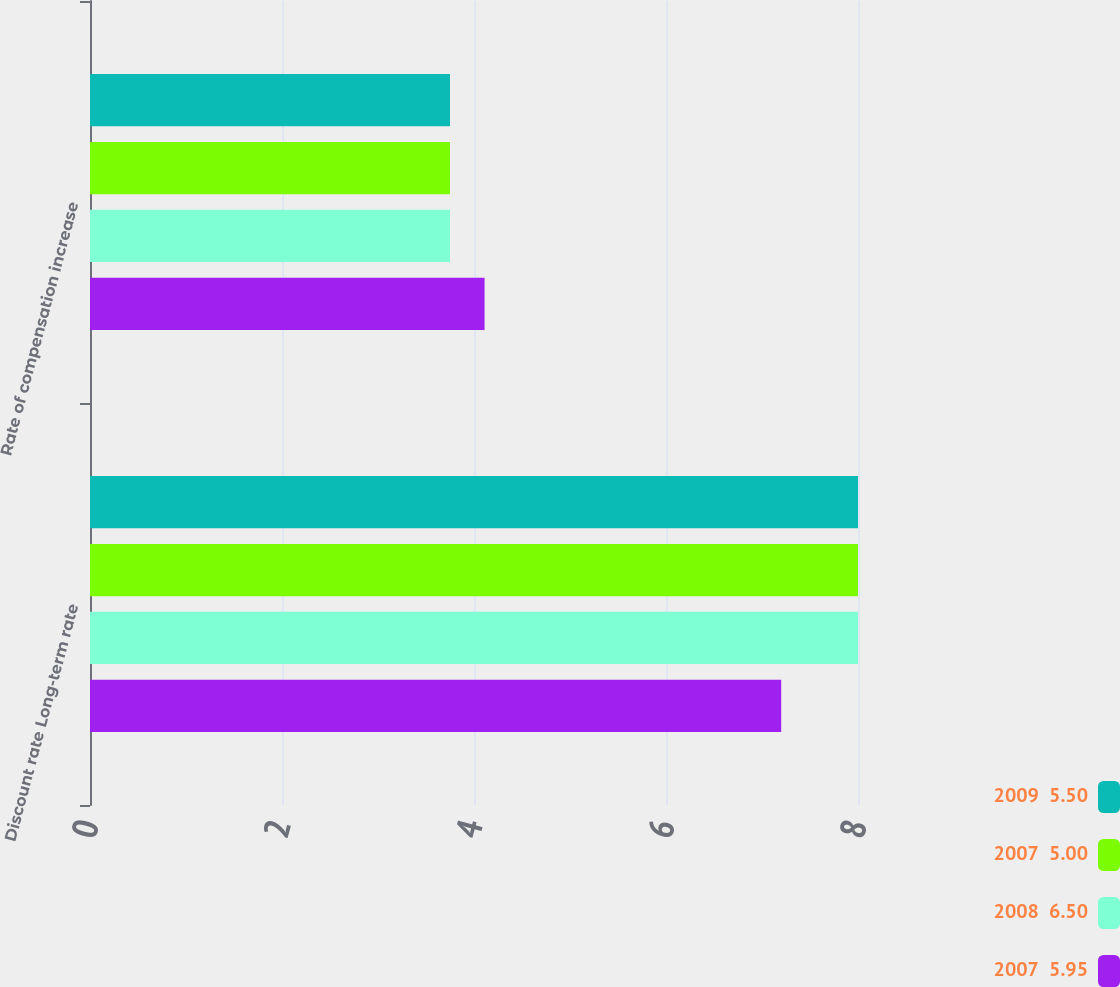Convert chart to OTSL. <chart><loc_0><loc_0><loc_500><loc_500><stacked_bar_chart><ecel><fcel>Discount rate Long-term rate<fcel>Rate of compensation increase<nl><fcel>2009  5.50<fcel>8<fcel>3.75<nl><fcel>2007  5.00<fcel>8<fcel>3.75<nl><fcel>2008  6.50<fcel>8<fcel>3.75<nl><fcel>2007  5.95<fcel>7.2<fcel>4.11<nl></chart> 